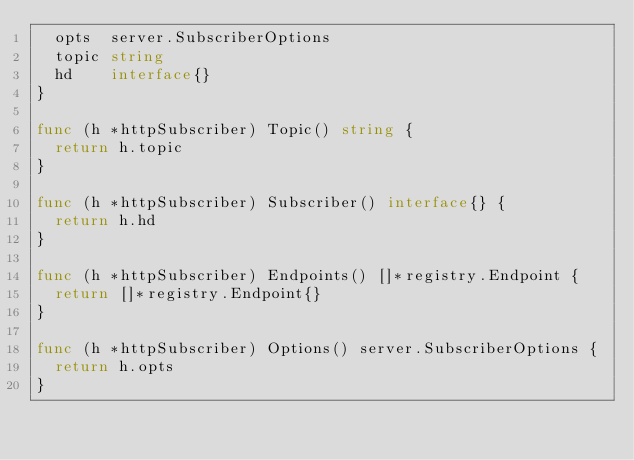<code> <loc_0><loc_0><loc_500><loc_500><_Go_>	opts  server.SubscriberOptions
	topic string
	hd    interface{}
}

func (h *httpSubscriber) Topic() string {
	return h.topic
}

func (h *httpSubscriber) Subscriber() interface{} {
	return h.hd
}

func (h *httpSubscriber) Endpoints() []*registry.Endpoint {
	return []*registry.Endpoint{}
}

func (h *httpSubscriber) Options() server.SubscriberOptions {
	return h.opts
}
</code> 